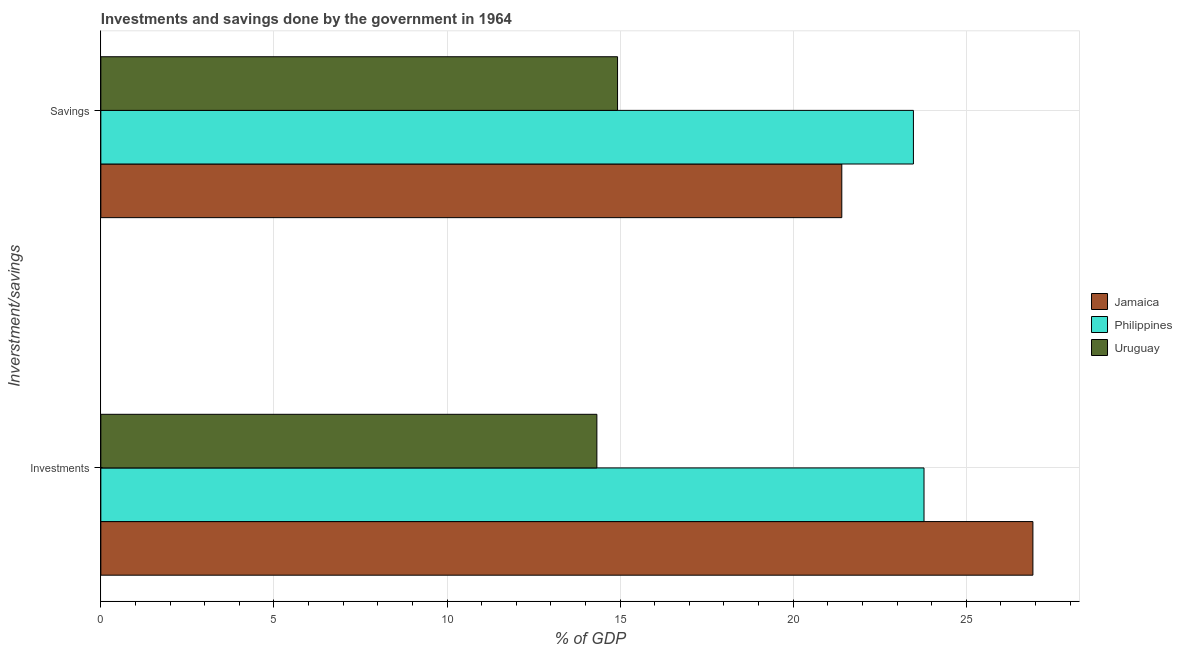How many groups of bars are there?
Your answer should be compact. 2. Are the number of bars per tick equal to the number of legend labels?
Ensure brevity in your answer.  Yes. Are the number of bars on each tick of the Y-axis equal?
Keep it short and to the point. Yes. What is the label of the 2nd group of bars from the top?
Give a very brief answer. Investments. What is the investments of government in Uruguay?
Give a very brief answer. 14.33. Across all countries, what is the maximum investments of government?
Provide a succinct answer. 26.92. Across all countries, what is the minimum savings of government?
Provide a succinct answer. 14.93. In which country was the savings of government maximum?
Offer a very short reply. Philippines. In which country was the savings of government minimum?
Provide a succinct answer. Uruguay. What is the total investments of government in the graph?
Give a very brief answer. 65.03. What is the difference between the savings of government in Uruguay and that in Philippines?
Offer a terse response. -8.55. What is the difference between the savings of government in Philippines and the investments of government in Uruguay?
Offer a very short reply. 9.14. What is the average savings of government per country?
Keep it short and to the point. 19.93. What is the difference between the savings of government and investments of government in Philippines?
Offer a terse response. -0.31. What is the ratio of the investments of government in Jamaica to that in Uruguay?
Your answer should be compact. 1.88. Is the investments of government in Jamaica less than that in Uruguay?
Provide a succinct answer. No. What does the 1st bar from the top in Investments represents?
Give a very brief answer. Uruguay. What does the 3rd bar from the bottom in Investments represents?
Your answer should be compact. Uruguay. Are all the bars in the graph horizontal?
Provide a succinct answer. Yes. How many countries are there in the graph?
Provide a short and direct response. 3. What is the difference between two consecutive major ticks on the X-axis?
Provide a succinct answer. 5. Are the values on the major ticks of X-axis written in scientific E-notation?
Your answer should be very brief. No. Does the graph contain any zero values?
Offer a terse response. No. Does the graph contain grids?
Give a very brief answer. Yes. Where does the legend appear in the graph?
Offer a very short reply. Center right. How many legend labels are there?
Your response must be concise. 3. What is the title of the graph?
Ensure brevity in your answer.  Investments and savings done by the government in 1964. Does "Least developed countries" appear as one of the legend labels in the graph?
Offer a terse response. No. What is the label or title of the X-axis?
Your answer should be very brief. % of GDP. What is the label or title of the Y-axis?
Keep it short and to the point. Inverstment/savings. What is the % of GDP in Jamaica in Investments?
Offer a very short reply. 26.92. What is the % of GDP of Philippines in Investments?
Your response must be concise. 23.78. What is the % of GDP in Uruguay in Investments?
Your response must be concise. 14.33. What is the % of GDP in Jamaica in Savings?
Your answer should be compact. 21.4. What is the % of GDP of Philippines in Savings?
Your answer should be compact. 23.47. What is the % of GDP in Uruguay in Savings?
Offer a terse response. 14.93. Across all Inverstment/savings, what is the maximum % of GDP in Jamaica?
Your answer should be very brief. 26.92. Across all Inverstment/savings, what is the maximum % of GDP of Philippines?
Ensure brevity in your answer.  23.78. Across all Inverstment/savings, what is the maximum % of GDP of Uruguay?
Provide a succinct answer. 14.93. Across all Inverstment/savings, what is the minimum % of GDP of Jamaica?
Provide a short and direct response. 21.4. Across all Inverstment/savings, what is the minimum % of GDP in Philippines?
Offer a terse response. 23.47. Across all Inverstment/savings, what is the minimum % of GDP in Uruguay?
Your response must be concise. 14.33. What is the total % of GDP of Jamaica in the graph?
Keep it short and to the point. 48.33. What is the total % of GDP in Philippines in the graph?
Give a very brief answer. 47.25. What is the total % of GDP of Uruguay in the graph?
Offer a terse response. 29.25. What is the difference between the % of GDP of Jamaica in Investments and that in Savings?
Provide a succinct answer. 5.52. What is the difference between the % of GDP of Philippines in Investments and that in Savings?
Your answer should be compact. 0.31. What is the difference between the % of GDP of Uruguay in Investments and that in Savings?
Ensure brevity in your answer.  -0.6. What is the difference between the % of GDP in Jamaica in Investments and the % of GDP in Philippines in Savings?
Your answer should be very brief. 3.45. What is the difference between the % of GDP in Jamaica in Investments and the % of GDP in Uruguay in Savings?
Offer a terse response. 12. What is the difference between the % of GDP in Philippines in Investments and the % of GDP in Uruguay in Savings?
Offer a terse response. 8.85. What is the average % of GDP in Jamaica per Inverstment/savings?
Make the answer very short. 24.16. What is the average % of GDP of Philippines per Inverstment/savings?
Keep it short and to the point. 23.62. What is the average % of GDP of Uruguay per Inverstment/savings?
Provide a succinct answer. 14.63. What is the difference between the % of GDP in Jamaica and % of GDP in Philippines in Investments?
Provide a short and direct response. 3.15. What is the difference between the % of GDP in Jamaica and % of GDP in Uruguay in Investments?
Your answer should be very brief. 12.59. What is the difference between the % of GDP of Philippines and % of GDP of Uruguay in Investments?
Ensure brevity in your answer.  9.45. What is the difference between the % of GDP in Jamaica and % of GDP in Philippines in Savings?
Your answer should be compact. -2.07. What is the difference between the % of GDP in Jamaica and % of GDP in Uruguay in Savings?
Give a very brief answer. 6.48. What is the difference between the % of GDP in Philippines and % of GDP in Uruguay in Savings?
Ensure brevity in your answer.  8.55. What is the ratio of the % of GDP in Jamaica in Investments to that in Savings?
Ensure brevity in your answer.  1.26. What is the ratio of the % of GDP in Philippines in Investments to that in Savings?
Give a very brief answer. 1.01. What is the ratio of the % of GDP in Uruguay in Investments to that in Savings?
Provide a short and direct response. 0.96. What is the difference between the highest and the second highest % of GDP of Jamaica?
Provide a succinct answer. 5.52. What is the difference between the highest and the second highest % of GDP in Philippines?
Provide a succinct answer. 0.31. What is the difference between the highest and the second highest % of GDP of Uruguay?
Provide a short and direct response. 0.6. What is the difference between the highest and the lowest % of GDP in Jamaica?
Give a very brief answer. 5.52. What is the difference between the highest and the lowest % of GDP of Philippines?
Keep it short and to the point. 0.31. What is the difference between the highest and the lowest % of GDP of Uruguay?
Provide a short and direct response. 0.6. 